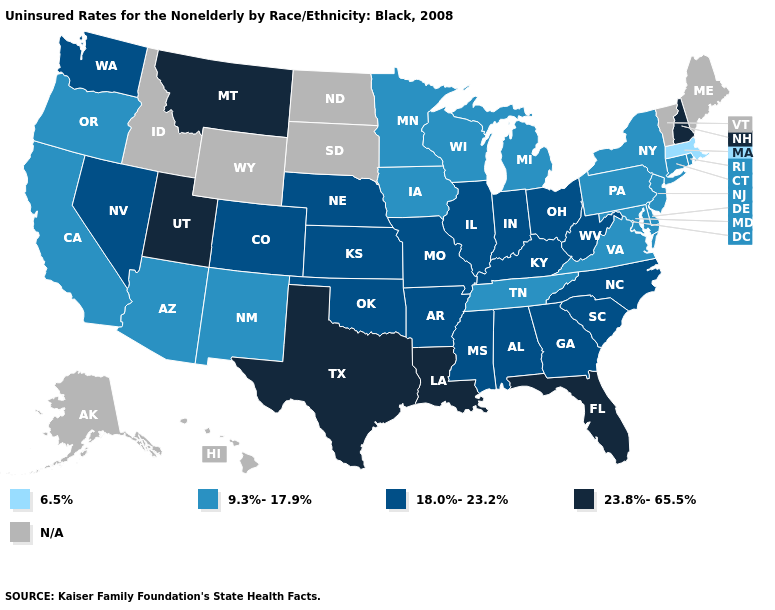Name the states that have a value in the range 18.0%-23.2%?
Short answer required. Alabama, Arkansas, Colorado, Georgia, Illinois, Indiana, Kansas, Kentucky, Mississippi, Missouri, Nebraska, Nevada, North Carolina, Ohio, Oklahoma, South Carolina, Washington, West Virginia. Among the states that border Minnesota , which have the lowest value?
Answer briefly. Iowa, Wisconsin. What is the highest value in states that border New Jersey?
Keep it brief. 9.3%-17.9%. What is the value of North Carolina?
Give a very brief answer. 18.0%-23.2%. What is the value of Ohio?
Short answer required. 18.0%-23.2%. Name the states that have a value in the range N/A?
Concise answer only. Alaska, Hawaii, Idaho, Maine, North Dakota, South Dakota, Vermont, Wyoming. Does the first symbol in the legend represent the smallest category?
Quick response, please. Yes. What is the lowest value in the MidWest?
Give a very brief answer. 9.3%-17.9%. What is the value of Vermont?
Short answer required. N/A. What is the value of Delaware?
Concise answer only. 9.3%-17.9%. What is the value of West Virginia?
Give a very brief answer. 18.0%-23.2%. What is the value of Idaho?
Concise answer only. N/A. What is the value of Iowa?
Keep it brief. 9.3%-17.9%. 